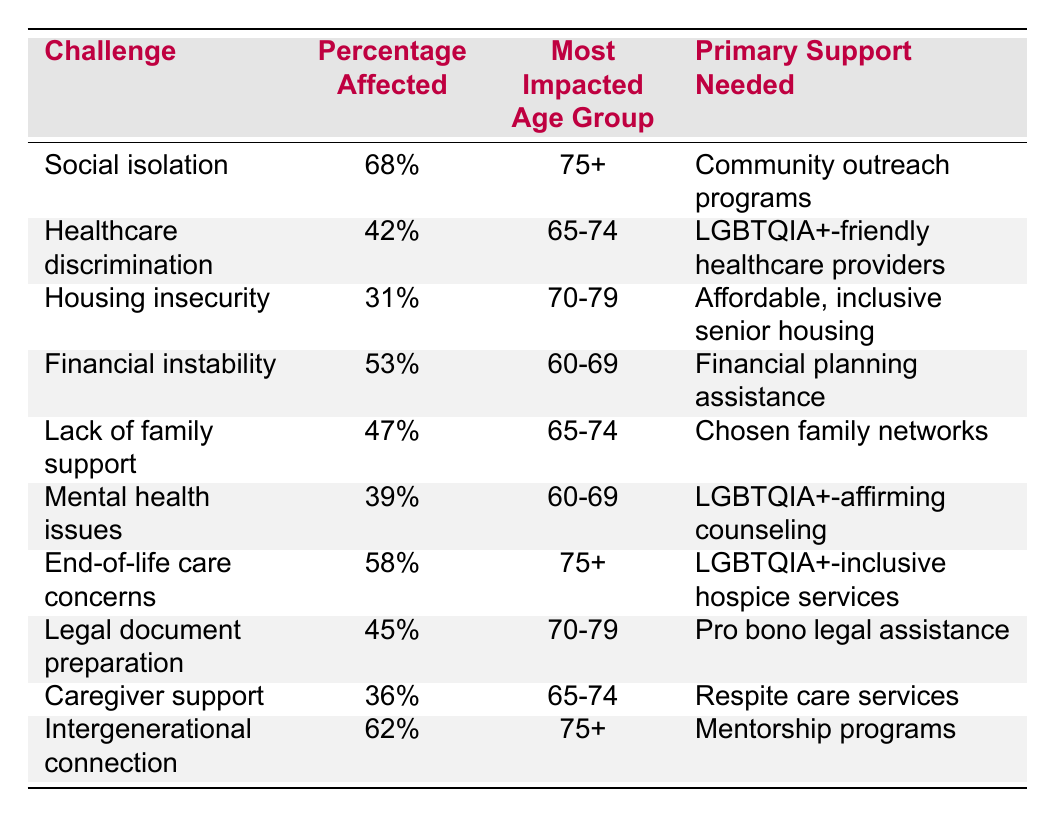What percentage of LGBTQIA+ seniors face social isolation? The table indicates that 68% of seniors report experiencing social isolation.
Answer: 68% Which age group is most affected by healthcare discrimination? According to the data, the most impacted age group for healthcare discrimination is 65-74 years old.
Answer: 65-74 What primary support is needed for those facing lack of family support? The table shows that chosen family networks are identified as the primary support needed for addressing lack of family support.
Answer: Chosen family networks How many challenges have a percentage affected of 50% or more? By reviewing the data in the table, the challenges with percentages of 50% or more are social isolation (68%), financial instability (53%), end-of-life care concerns (58%), and healthcare discrimination (42%), which sums to four.
Answer: 4 Is housing insecurity a challenge faced by 70-79-year-olds? Yes, the data indicates that housing insecurity is indeed a challenge faced by the 70-79 age group, with 31% affected.
Answer: Yes What is the percentage of seniors affected by mental health issues? The table shows that 39% of seniors report facing mental health issues.
Answer: 39% Which challenge has the highest percentage of affected individuals? The highest percentage of affected individuals is for social isolation at 68%.
Answer: Social isolation If we calculate the average percentage of the challenges between 60-69 age group, what would that be? The affected percentages for the 60-69 age group are 53% (financial instability) and 39% (mental health issues). Adding these values gives 92%. Dividing by 2 results in an average of 46%.
Answer: 46% What is the primary support needed for end-of-life care concerns? The table indicates that LGBTQIA+-inclusive hospice services are the primary support needed for end-of-life care concerns.
Answer: LGBTQIA+-inclusive hospice services Which challenges affect the 75+ age group? The challenges affecting the 75+ age group include social isolation (68%) and end-of-life care concerns (58%), as well as intergenerational connection (62%).
Answer: Social isolation, end-of-life care concerns, intergenerational connection 